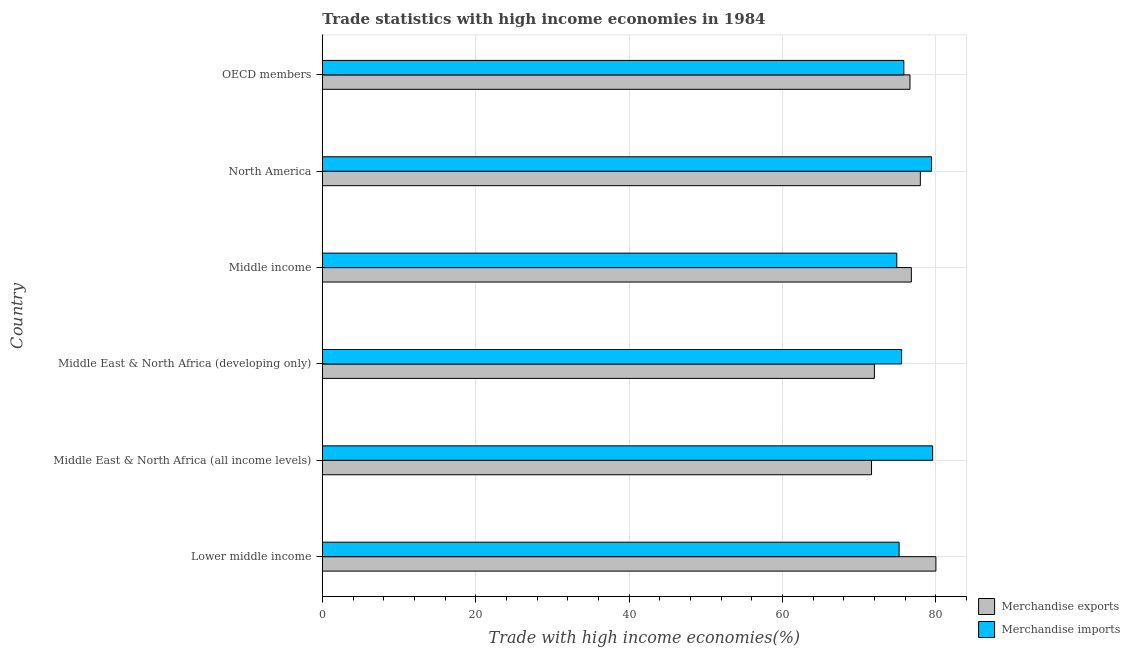How many groups of bars are there?
Ensure brevity in your answer.  6. Are the number of bars on each tick of the Y-axis equal?
Give a very brief answer. Yes. How many bars are there on the 1st tick from the top?
Your answer should be compact. 2. What is the label of the 5th group of bars from the top?
Give a very brief answer. Middle East & North Africa (all income levels). What is the merchandise exports in Middle East & North Africa (developing only)?
Your answer should be very brief. 71.99. Across all countries, what is the maximum merchandise imports?
Provide a short and direct response. 79.59. Across all countries, what is the minimum merchandise imports?
Provide a short and direct response. 74.91. In which country was the merchandise exports maximum?
Make the answer very short. Lower middle income. In which country was the merchandise exports minimum?
Keep it short and to the point. Middle East & North Africa (all income levels). What is the total merchandise exports in the graph?
Offer a terse response. 455.06. What is the difference between the merchandise imports in Lower middle income and that in Middle income?
Keep it short and to the point. 0.3. What is the difference between the merchandise imports in Middle East & North Africa (all income levels) and the merchandise exports in Middle East & North Africa (developing only)?
Offer a terse response. 7.6. What is the average merchandise exports per country?
Provide a short and direct response. 75.84. What is the difference between the merchandise imports and merchandise exports in Middle income?
Offer a terse response. -1.9. In how many countries, is the merchandise exports greater than 36 %?
Provide a short and direct response. 6. What is the ratio of the merchandise imports in Middle East & North Africa (all income levels) to that in Middle East & North Africa (developing only)?
Provide a short and direct response. 1.05. Is the difference between the merchandise imports in Middle income and OECD members greater than the difference between the merchandise exports in Middle income and OECD members?
Your answer should be compact. No. What is the difference between the highest and the second highest merchandise imports?
Make the answer very short. 0.15. What is the difference between the highest and the lowest merchandise imports?
Ensure brevity in your answer.  4.68. What does the 1st bar from the bottom in Middle income represents?
Your response must be concise. Merchandise exports. How many bars are there?
Keep it short and to the point. 12. How many countries are there in the graph?
Offer a terse response. 6. What is the difference between two consecutive major ticks on the X-axis?
Ensure brevity in your answer.  20. Are the values on the major ticks of X-axis written in scientific E-notation?
Offer a very short reply. No. Does the graph contain any zero values?
Offer a terse response. No. Where does the legend appear in the graph?
Make the answer very short. Bottom right. How are the legend labels stacked?
Your response must be concise. Vertical. What is the title of the graph?
Offer a very short reply. Trade statistics with high income economies in 1984. Does "GDP per capita" appear as one of the legend labels in the graph?
Make the answer very short. No. What is the label or title of the X-axis?
Ensure brevity in your answer.  Trade with high income economies(%). What is the Trade with high income economies(%) in Merchandise exports in Lower middle income?
Ensure brevity in your answer.  80.02. What is the Trade with high income economies(%) in Merchandise imports in Lower middle income?
Provide a succinct answer. 75.22. What is the Trade with high income economies(%) of Merchandise exports in Middle East & North Africa (all income levels)?
Provide a short and direct response. 71.62. What is the Trade with high income economies(%) in Merchandise imports in Middle East & North Africa (all income levels)?
Give a very brief answer. 79.59. What is the Trade with high income economies(%) of Merchandise exports in Middle East & North Africa (developing only)?
Make the answer very short. 71.99. What is the Trade with high income economies(%) in Merchandise imports in Middle East & North Africa (developing only)?
Give a very brief answer. 75.54. What is the Trade with high income economies(%) of Merchandise exports in Middle income?
Your response must be concise. 76.81. What is the Trade with high income economies(%) in Merchandise imports in Middle income?
Offer a very short reply. 74.91. What is the Trade with high income economies(%) of Merchandise exports in North America?
Ensure brevity in your answer.  77.98. What is the Trade with high income economies(%) in Merchandise imports in North America?
Keep it short and to the point. 79.44. What is the Trade with high income economies(%) in Merchandise exports in OECD members?
Your answer should be very brief. 76.63. What is the Trade with high income economies(%) in Merchandise imports in OECD members?
Ensure brevity in your answer.  75.83. Across all countries, what is the maximum Trade with high income economies(%) in Merchandise exports?
Provide a short and direct response. 80.02. Across all countries, what is the maximum Trade with high income economies(%) in Merchandise imports?
Your answer should be compact. 79.59. Across all countries, what is the minimum Trade with high income economies(%) of Merchandise exports?
Your answer should be compact. 71.62. Across all countries, what is the minimum Trade with high income economies(%) of Merchandise imports?
Offer a terse response. 74.91. What is the total Trade with high income economies(%) of Merchandise exports in the graph?
Offer a very short reply. 455.06. What is the total Trade with high income economies(%) of Merchandise imports in the graph?
Make the answer very short. 460.54. What is the difference between the Trade with high income economies(%) of Merchandise exports in Lower middle income and that in Middle East & North Africa (all income levels)?
Offer a very short reply. 8.4. What is the difference between the Trade with high income economies(%) in Merchandise imports in Lower middle income and that in Middle East & North Africa (all income levels)?
Make the answer very short. -4.37. What is the difference between the Trade with high income economies(%) in Merchandise exports in Lower middle income and that in Middle East & North Africa (developing only)?
Ensure brevity in your answer.  8.02. What is the difference between the Trade with high income economies(%) of Merchandise imports in Lower middle income and that in Middle East & North Africa (developing only)?
Keep it short and to the point. -0.33. What is the difference between the Trade with high income economies(%) in Merchandise exports in Lower middle income and that in Middle income?
Offer a very short reply. 3.2. What is the difference between the Trade with high income economies(%) in Merchandise imports in Lower middle income and that in Middle income?
Your answer should be compact. 0.3. What is the difference between the Trade with high income economies(%) in Merchandise exports in Lower middle income and that in North America?
Provide a succinct answer. 2.03. What is the difference between the Trade with high income economies(%) in Merchandise imports in Lower middle income and that in North America?
Provide a short and direct response. -4.23. What is the difference between the Trade with high income economies(%) of Merchandise exports in Lower middle income and that in OECD members?
Offer a terse response. 3.38. What is the difference between the Trade with high income economies(%) in Merchandise imports in Lower middle income and that in OECD members?
Make the answer very short. -0.61. What is the difference between the Trade with high income economies(%) in Merchandise exports in Middle East & North Africa (all income levels) and that in Middle East & North Africa (developing only)?
Make the answer very short. -0.37. What is the difference between the Trade with high income economies(%) of Merchandise imports in Middle East & North Africa (all income levels) and that in Middle East & North Africa (developing only)?
Offer a very short reply. 4.05. What is the difference between the Trade with high income economies(%) of Merchandise exports in Middle East & North Africa (all income levels) and that in Middle income?
Offer a very short reply. -5.19. What is the difference between the Trade with high income economies(%) of Merchandise imports in Middle East & North Africa (all income levels) and that in Middle income?
Keep it short and to the point. 4.68. What is the difference between the Trade with high income economies(%) in Merchandise exports in Middle East & North Africa (all income levels) and that in North America?
Keep it short and to the point. -6.37. What is the difference between the Trade with high income economies(%) in Merchandise imports in Middle East & North Africa (all income levels) and that in North America?
Ensure brevity in your answer.  0.15. What is the difference between the Trade with high income economies(%) in Merchandise exports in Middle East & North Africa (all income levels) and that in OECD members?
Make the answer very short. -5.01. What is the difference between the Trade with high income economies(%) of Merchandise imports in Middle East & North Africa (all income levels) and that in OECD members?
Make the answer very short. 3.76. What is the difference between the Trade with high income economies(%) of Merchandise exports in Middle East & North Africa (developing only) and that in Middle income?
Your answer should be very brief. -4.82. What is the difference between the Trade with high income economies(%) of Merchandise imports in Middle East & North Africa (developing only) and that in Middle income?
Your response must be concise. 0.63. What is the difference between the Trade with high income economies(%) in Merchandise exports in Middle East & North Africa (developing only) and that in North America?
Keep it short and to the point. -5.99. What is the difference between the Trade with high income economies(%) in Merchandise imports in Middle East & North Africa (developing only) and that in North America?
Offer a terse response. -3.9. What is the difference between the Trade with high income economies(%) of Merchandise exports in Middle East & North Africa (developing only) and that in OECD members?
Your answer should be very brief. -4.64. What is the difference between the Trade with high income economies(%) of Merchandise imports in Middle East & North Africa (developing only) and that in OECD members?
Make the answer very short. -0.29. What is the difference between the Trade with high income economies(%) in Merchandise exports in Middle income and that in North America?
Your response must be concise. -1.17. What is the difference between the Trade with high income economies(%) in Merchandise imports in Middle income and that in North America?
Offer a very short reply. -4.53. What is the difference between the Trade with high income economies(%) of Merchandise exports in Middle income and that in OECD members?
Ensure brevity in your answer.  0.18. What is the difference between the Trade with high income economies(%) in Merchandise imports in Middle income and that in OECD members?
Give a very brief answer. -0.92. What is the difference between the Trade with high income economies(%) in Merchandise exports in North America and that in OECD members?
Keep it short and to the point. 1.35. What is the difference between the Trade with high income economies(%) in Merchandise imports in North America and that in OECD members?
Your answer should be compact. 3.61. What is the difference between the Trade with high income economies(%) of Merchandise exports in Lower middle income and the Trade with high income economies(%) of Merchandise imports in Middle East & North Africa (all income levels)?
Your answer should be very brief. 0.42. What is the difference between the Trade with high income economies(%) of Merchandise exports in Lower middle income and the Trade with high income economies(%) of Merchandise imports in Middle East & North Africa (developing only)?
Provide a short and direct response. 4.47. What is the difference between the Trade with high income economies(%) in Merchandise exports in Lower middle income and the Trade with high income economies(%) in Merchandise imports in Middle income?
Your answer should be very brief. 5.1. What is the difference between the Trade with high income economies(%) in Merchandise exports in Lower middle income and the Trade with high income economies(%) in Merchandise imports in North America?
Make the answer very short. 0.57. What is the difference between the Trade with high income economies(%) in Merchandise exports in Lower middle income and the Trade with high income economies(%) in Merchandise imports in OECD members?
Your response must be concise. 4.18. What is the difference between the Trade with high income economies(%) of Merchandise exports in Middle East & North Africa (all income levels) and the Trade with high income economies(%) of Merchandise imports in Middle East & North Africa (developing only)?
Ensure brevity in your answer.  -3.92. What is the difference between the Trade with high income economies(%) of Merchandise exports in Middle East & North Africa (all income levels) and the Trade with high income economies(%) of Merchandise imports in Middle income?
Offer a terse response. -3.29. What is the difference between the Trade with high income economies(%) of Merchandise exports in Middle East & North Africa (all income levels) and the Trade with high income economies(%) of Merchandise imports in North America?
Ensure brevity in your answer.  -7.82. What is the difference between the Trade with high income economies(%) in Merchandise exports in Middle East & North Africa (all income levels) and the Trade with high income economies(%) in Merchandise imports in OECD members?
Your answer should be very brief. -4.21. What is the difference between the Trade with high income economies(%) in Merchandise exports in Middle East & North Africa (developing only) and the Trade with high income economies(%) in Merchandise imports in Middle income?
Your answer should be very brief. -2.92. What is the difference between the Trade with high income economies(%) of Merchandise exports in Middle East & North Africa (developing only) and the Trade with high income economies(%) of Merchandise imports in North America?
Offer a terse response. -7.45. What is the difference between the Trade with high income economies(%) of Merchandise exports in Middle East & North Africa (developing only) and the Trade with high income economies(%) of Merchandise imports in OECD members?
Offer a very short reply. -3.84. What is the difference between the Trade with high income economies(%) of Merchandise exports in Middle income and the Trade with high income economies(%) of Merchandise imports in North America?
Make the answer very short. -2.63. What is the difference between the Trade with high income economies(%) in Merchandise exports in Middle income and the Trade with high income economies(%) in Merchandise imports in OECD members?
Keep it short and to the point. 0.98. What is the difference between the Trade with high income economies(%) of Merchandise exports in North America and the Trade with high income economies(%) of Merchandise imports in OECD members?
Offer a very short reply. 2.15. What is the average Trade with high income economies(%) of Merchandise exports per country?
Provide a succinct answer. 75.84. What is the average Trade with high income economies(%) of Merchandise imports per country?
Your answer should be compact. 76.76. What is the difference between the Trade with high income economies(%) in Merchandise exports and Trade with high income economies(%) in Merchandise imports in Lower middle income?
Your answer should be very brief. 4.8. What is the difference between the Trade with high income economies(%) in Merchandise exports and Trade with high income economies(%) in Merchandise imports in Middle East & North Africa (all income levels)?
Keep it short and to the point. -7.97. What is the difference between the Trade with high income economies(%) in Merchandise exports and Trade with high income economies(%) in Merchandise imports in Middle East & North Africa (developing only)?
Ensure brevity in your answer.  -3.55. What is the difference between the Trade with high income economies(%) of Merchandise exports and Trade with high income economies(%) of Merchandise imports in Middle income?
Keep it short and to the point. 1.9. What is the difference between the Trade with high income economies(%) in Merchandise exports and Trade with high income economies(%) in Merchandise imports in North America?
Give a very brief answer. -1.46. What is the difference between the Trade with high income economies(%) of Merchandise exports and Trade with high income economies(%) of Merchandise imports in OECD members?
Make the answer very short. 0.8. What is the ratio of the Trade with high income economies(%) in Merchandise exports in Lower middle income to that in Middle East & North Africa (all income levels)?
Ensure brevity in your answer.  1.12. What is the ratio of the Trade with high income economies(%) of Merchandise imports in Lower middle income to that in Middle East & North Africa (all income levels)?
Your answer should be compact. 0.94. What is the ratio of the Trade with high income economies(%) of Merchandise exports in Lower middle income to that in Middle East & North Africa (developing only)?
Give a very brief answer. 1.11. What is the ratio of the Trade with high income economies(%) in Merchandise exports in Lower middle income to that in Middle income?
Give a very brief answer. 1.04. What is the ratio of the Trade with high income economies(%) in Merchandise imports in Lower middle income to that in North America?
Keep it short and to the point. 0.95. What is the ratio of the Trade with high income economies(%) in Merchandise exports in Lower middle income to that in OECD members?
Your answer should be very brief. 1.04. What is the ratio of the Trade with high income economies(%) of Merchandise imports in Lower middle income to that in OECD members?
Provide a succinct answer. 0.99. What is the ratio of the Trade with high income economies(%) in Merchandise imports in Middle East & North Africa (all income levels) to that in Middle East & North Africa (developing only)?
Provide a short and direct response. 1.05. What is the ratio of the Trade with high income economies(%) of Merchandise exports in Middle East & North Africa (all income levels) to that in Middle income?
Ensure brevity in your answer.  0.93. What is the ratio of the Trade with high income economies(%) of Merchandise imports in Middle East & North Africa (all income levels) to that in Middle income?
Keep it short and to the point. 1.06. What is the ratio of the Trade with high income economies(%) in Merchandise exports in Middle East & North Africa (all income levels) to that in North America?
Your response must be concise. 0.92. What is the ratio of the Trade with high income economies(%) of Merchandise imports in Middle East & North Africa (all income levels) to that in North America?
Your answer should be very brief. 1. What is the ratio of the Trade with high income economies(%) of Merchandise exports in Middle East & North Africa (all income levels) to that in OECD members?
Give a very brief answer. 0.93. What is the ratio of the Trade with high income economies(%) of Merchandise imports in Middle East & North Africa (all income levels) to that in OECD members?
Offer a very short reply. 1.05. What is the ratio of the Trade with high income economies(%) of Merchandise exports in Middle East & North Africa (developing only) to that in Middle income?
Offer a terse response. 0.94. What is the ratio of the Trade with high income economies(%) of Merchandise imports in Middle East & North Africa (developing only) to that in Middle income?
Provide a succinct answer. 1.01. What is the ratio of the Trade with high income economies(%) of Merchandise exports in Middle East & North Africa (developing only) to that in North America?
Ensure brevity in your answer.  0.92. What is the ratio of the Trade with high income economies(%) of Merchandise imports in Middle East & North Africa (developing only) to that in North America?
Keep it short and to the point. 0.95. What is the ratio of the Trade with high income economies(%) in Merchandise exports in Middle East & North Africa (developing only) to that in OECD members?
Ensure brevity in your answer.  0.94. What is the ratio of the Trade with high income economies(%) of Merchandise imports in Middle income to that in North America?
Your answer should be compact. 0.94. What is the ratio of the Trade with high income economies(%) of Merchandise exports in Middle income to that in OECD members?
Give a very brief answer. 1. What is the ratio of the Trade with high income economies(%) of Merchandise imports in Middle income to that in OECD members?
Offer a very short reply. 0.99. What is the ratio of the Trade with high income economies(%) of Merchandise exports in North America to that in OECD members?
Offer a terse response. 1.02. What is the ratio of the Trade with high income economies(%) of Merchandise imports in North America to that in OECD members?
Give a very brief answer. 1.05. What is the difference between the highest and the second highest Trade with high income economies(%) of Merchandise exports?
Keep it short and to the point. 2.03. What is the difference between the highest and the second highest Trade with high income economies(%) in Merchandise imports?
Ensure brevity in your answer.  0.15. What is the difference between the highest and the lowest Trade with high income economies(%) in Merchandise exports?
Make the answer very short. 8.4. What is the difference between the highest and the lowest Trade with high income economies(%) of Merchandise imports?
Ensure brevity in your answer.  4.68. 